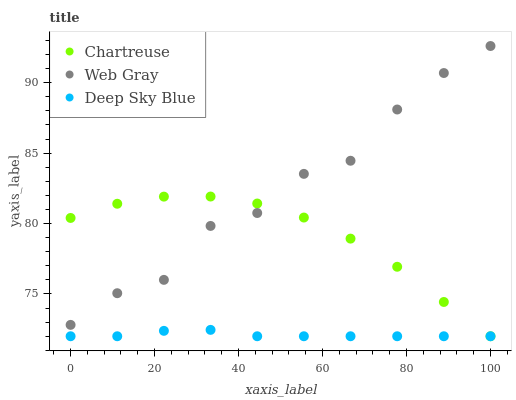Does Deep Sky Blue have the minimum area under the curve?
Answer yes or no. Yes. Does Web Gray have the maximum area under the curve?
Answer yes or no. Yes. Does Web Gray have the minimum area under the curve?
Answer yes or no. No. Does Deep Sky Blue have the maximum area under the curve?
Answer yes or no. No. Is Deep Sky Blue the smoothest?
Answer yes or no. Yes. Is Web Gray the roughest?
Answer yes or no. Yes. Is Web Gray the smoothest?
Answer yes or no. No. Is Deep Sky Blue the roughest?
Answer yes or no. No. Does Chartreuse have the lowest value?
Answer yes or no. Yes. Does Web Gray have the lowest value?
Answer yes or no. No. Does Web Gray have the highest value?
Answer yes or no. Yes. Does Deep Sky Blue have the highest value?
Answer yes or no. No. Is Deep Sky Blue less than Web Gray?
Answer yes or no. Yes. Is Web Gray greater than Deep Sky Blue?
Answer yes or no. Yes. Does Web Gray intersect Chartreuse?
Answer yes or no. Yes. Is Web Gray less than Chartreuse?
Answer yes or no. No. Is Web Gray greater than Chartreuse?
Answer yes or no. No. Does Deep Sky Blue intersect Web Gray?
Answer yes or no. No. 